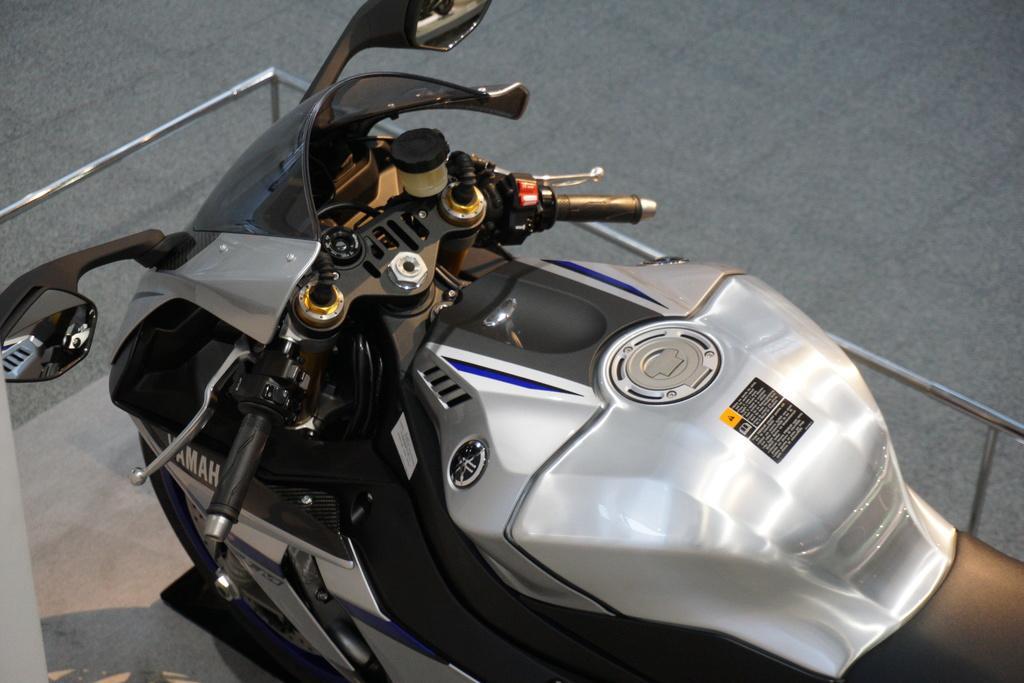In one or two sentences, can you explain what this image depicts? In the image in the center we can see one silver color bike,fence and floor. 